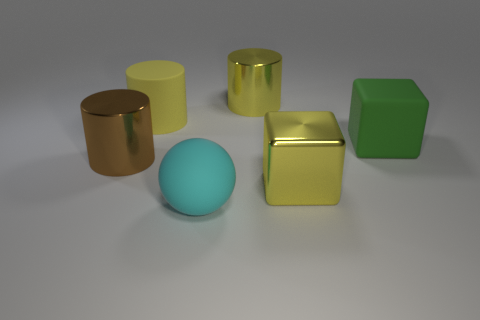How many objects are there and can you describe their arrangement? There are five objects in the image, arranged somewhat centrally but with no precise pattern. From left to right, we see a gold cylinder, a yellow cylinder, a sphere with a cyan rubbery texture, a shiny gold cube, and finally a green cube.  Do the objects have anything in common? While the objects differ in shape and color, they all have a matte or shiny finish and are rendered in a simple, minimalist style. They share a common theme of geometric simplicity and visual purity. 